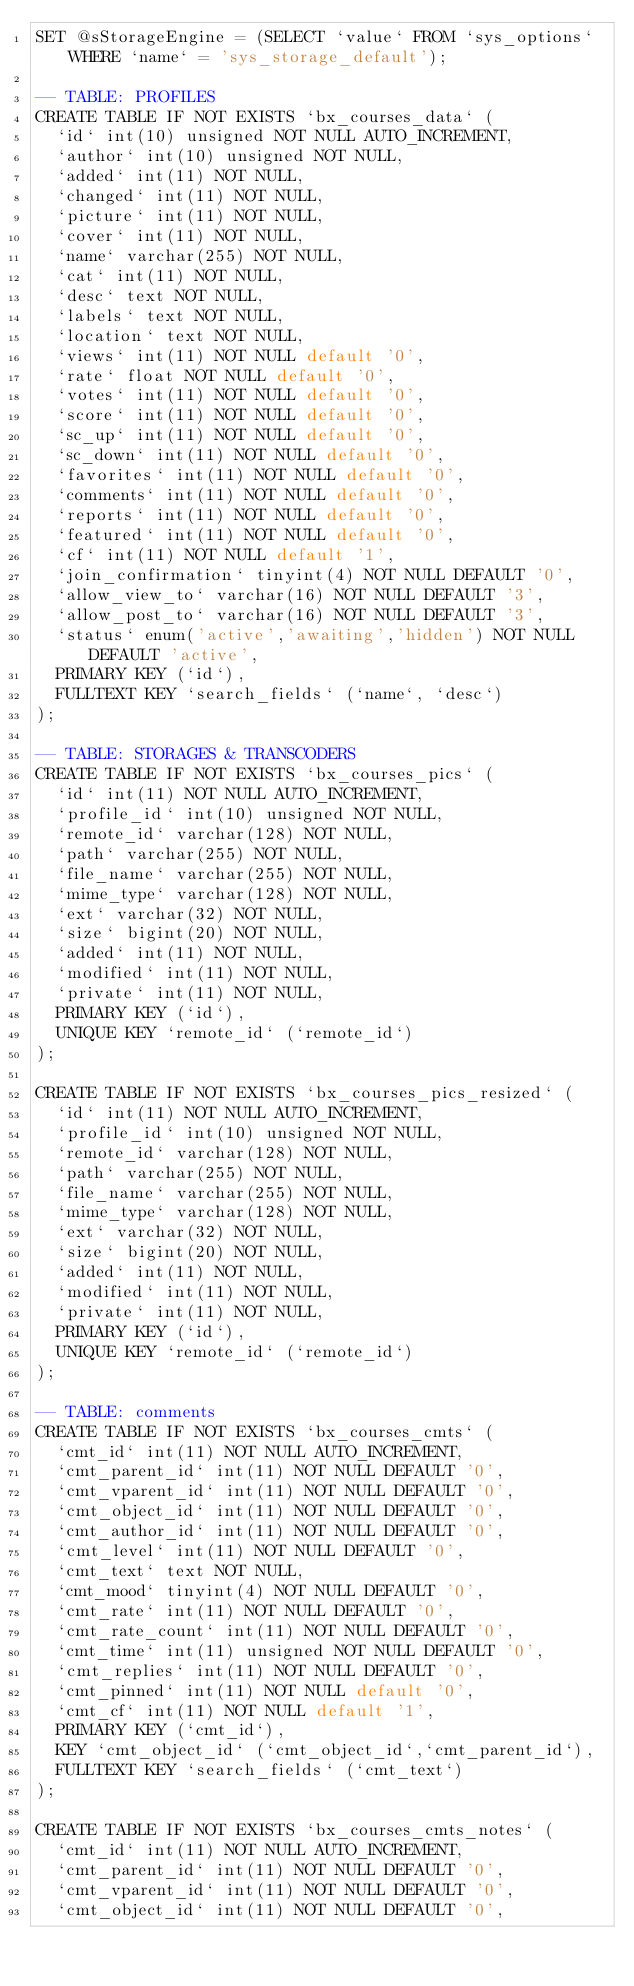<code> <loc_0><loc_0><loc_500><loc_500><_SQL_>SET @sStorageEngine = (SELECT `value` FROM `sys_options` WHERE `name` = 'sys_storage_default');

-- TABLE: PROFILES
CREATE TABLE IF NOT EXISTS `bx_courses_data` (
  `id` int(10) unsigned NOT NULL AUTO_INCREMENT,
  `author` int(10) unsigned NOT NULL,
  `added` int(11) NOT NULL,
  `changed` int(11) NOT NULL,
  `picture` int(11) NOT NULL,
  `cover` int(11) NOT NULL,
  `name` varchar(255) NOT NULL,
  `cat` int(11) NOT NULL,
  `desc` text NOT NULL,
  `labels` text NOT NULL,
  `location` text NOT NULL,
  `views` int(11) NOT NULL default '0',
  `rate` float NOT NULL default '0',
  `votes` int(11) NOT NULL default '0',
  `score` int(11) NOT NULL default '0',
  `sc_up` int(11) NOT NULL default '0',
  `sc_down` int(11) NOT NULL default '0',
  `favorites` int(11) NOT NULL default '0',
  `comments` int(11) NOT NULL default '0',
  `reports` int(11) NOT NULL default '0',
  `featured` int(11) NOT NULL default '0',
  `cf` int(11) NOT NULL default '1',
  `join_confirmation` tinyint(4) NOT NULL DEFAULT '0',
  `allow_view_to` varchar(16) NOT NULL DEFAULT '3',
  `allow_post_to` varchar(16) NOT NULL DEFAULT '3',
  `status` enum('active','awaiting','hidden') NOT NULL DEFAULT 'active',
  PRIMARY KEY (`id`),
  FULLTEXT KEY `search_fields` (`name`, `desc`)
);

-- TABLE: STORAGES & TRANSCODERS
CREATE TABLE IF NOT EXISTS `bx_courses_pics` (
  `id` int(11) NOT NULL AUTO_INCREMENT,
  `profile_id` int(10) unsigned NOT NULL,
  `remote_id` varchar(128) NOT NULL,
  `path` varchar(255) NOT NULL,
  `file_name` varchar(255) NOT NULL,
  `mime_type` varchar(128) NOT NULL,
  `ext` varchar(32) NOT NULL,
  `size` bigint(20) NOT NULL,
  `added` int(11) NOT NULL,
  `modified` int(11) NOT NULL,
  `private` int(11) NOT NULL,
  PRIMARY KEY (`id`),
  UNIQUE KEY `remote_id` (`remote_id`)
);

CREATE TABLE IF NOT EXISTS `bx_courses_pics_resized` (
  `id` int(11) NOT NULL AUTO_INCREMENT,
  `profile_id` int(10) unsigned NOT NULL,
  `remote_id` varchar(128) NOT NULL,
  `path` varchar(255) NOT NULL,
  `file_name` varchar(255) NOT NULL,
  `mime_type` varchar(128) NOT NULL,
  `ext` varchar(32) NOT NULL,
  `size` bigint(20) NOT NULL,
  `added` int(11) NOT NULL,
  `modified` int(11) NOT NULL,
  `private` int(11) NOT NULL,
  PRIMARY KEY (`id`),
  UNIQUE KEY `remote_id` (`remote_id`)
);

-- TABLE: comments
CREATE TABLE IF NOT EXISTS `bx_courses_cmts` (
  `cmt_id` int(11) NOT NULL AUTO_INCREMENT,
  `cmt_parent_id` int(11) NOT NULL DEFAULT '0',
  `cmt_vparent_id` int(11) NOT NULL DEFAULT '0',
  `cmt_object_id` int(11) NOT NULL DEFAULT '0',
  `cmt_author_id` int(11) NOT NULL DEFAULT '0',
  `cmt_level` int(11) NOT NULL DEFAULT '0',
  `cmt_text` text NOT NULL,
  `cmt_mood` tinyint(4) NOT NULL DEFAULT '0',
  `cmt_rate` int(11) NOT NULL DEFAULT '0',
  `cmt_rate_count` int(11) NOT NULL DEFAULT '0',
  `cmt_time` int(11) unsigned NOT NULL DEFAULT '0',
  `cmt_replies` int(11) NOT NULL DEFAULT '0',
  `cmt_pinned` int(11) NOT NULL default '0',
  `cmt_cf` int(11) NOT NULL default '1',
  PRIMARY KEY (`cmt_id`),
  KEY `cmt_object_id` (`cmt_object_id`,`cmt_parent_id`),
  FULLTEXT KEY `search_fields` (`cmt_text`)
);

CREATE TABLE IF NOT EXISTS `bx_courses_cmts_notes` (
  `cmt_id` int(11) NOT NULL AUTO_INCREMENT,
  `cmt_parent_id` int(11) NOT NULL DEFAULT '0',
  `cmt_vparent_id` int(11) NOT NULL DEFAULT '0',
  `cmt_object_id` int(11) NOT NULL DEFAULT '0',</code> 